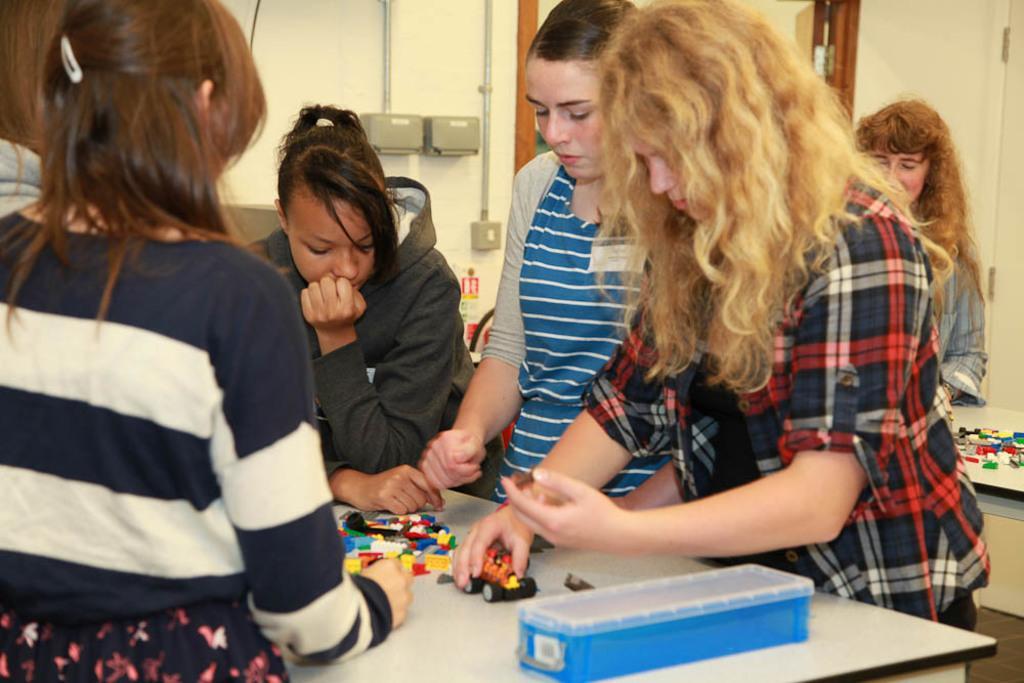Could you give a brief overview of what you see in this image? In this image I can see a few people around. I can see few toys and box on the tables. Back I can see a wall and door. 